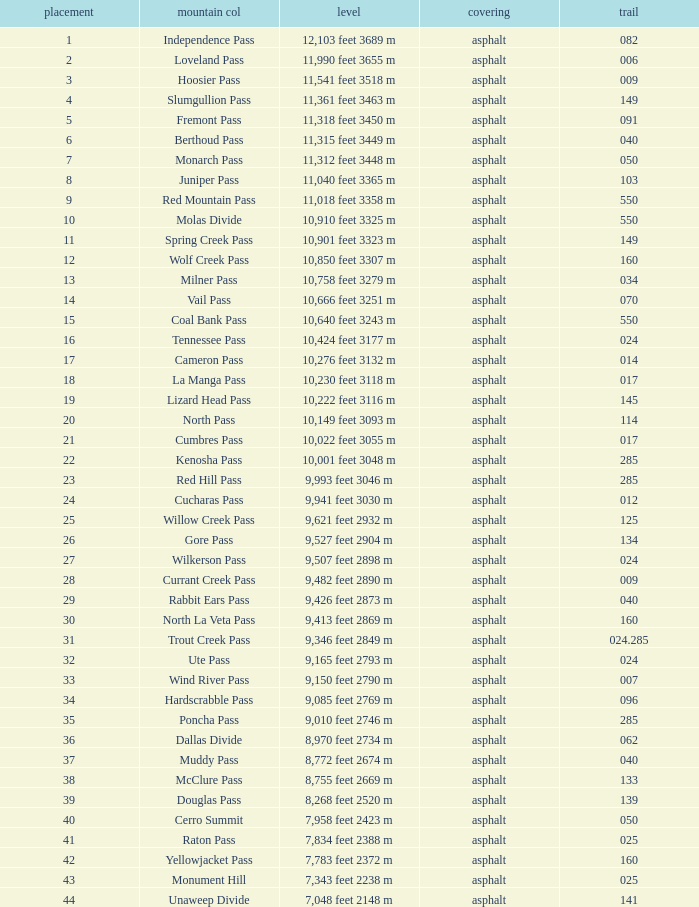What is the Surface of the Route less than 7? Asphalt. 